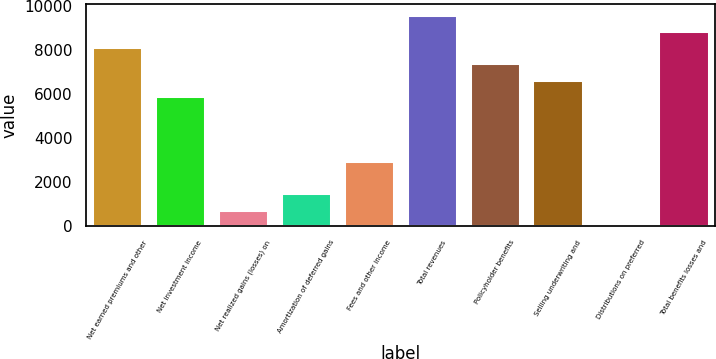Convert chart. <chart><loc_0><loc_0><loc_500><loc_500><bar_chart><fcel>Net earned premiums and other<fcel>Net investment income<fcel>Net realized gains (losses) on<fcel>Amortization of deferred gains<fcel>Fees and other income<fcel>Total revenues<fcel>Policyholder benefits<fcel>Selling underwriting and<fcel>Distributions on preferred<fcel>Total benefits losses and<nl><fcel>8144.2<fcel>5923.6<fcel>742.2<fcel>1482.4<fcel>2962.8<fcel>9624.6<fcel>7404<fcel>6663.8<fcel>2<fcel>8884.4<nl></chart> 